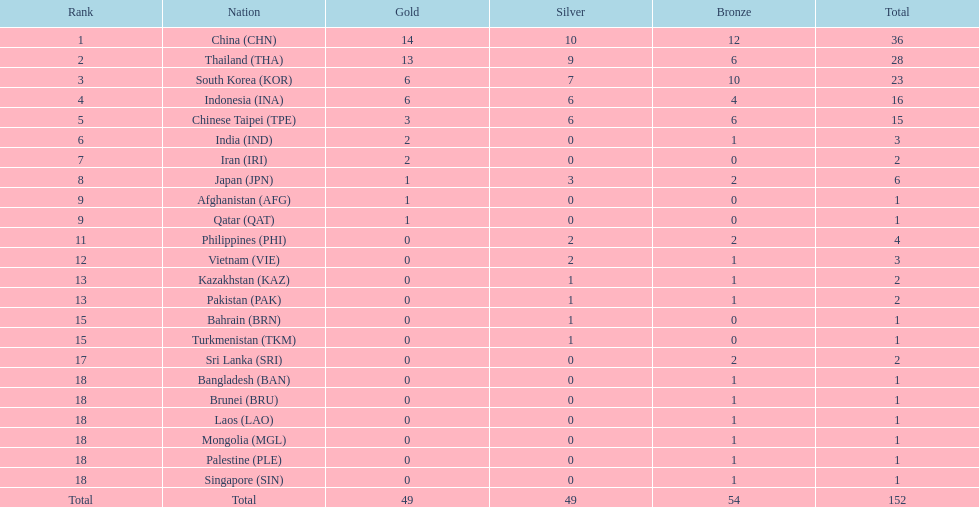How many nations obtained no silver medals whatsoever? 11. 